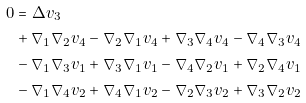Convert formula to latex. <formula><loc_0><loc_0><loc_500><loc_500>0 & = \Delta v _ { 3 } \\ & + \nabla _ { 1 } \nabla _ { 2 } v _ { 4 } - \nabla _ { 2 } \nabla _ { 1 } v _ { 4 } + \nabla _ { 3 } \nabla _ { 4 } v _ { 4 } - \nabla _ { 4 } \nabla _ { 3 } v _ { 4 } \\ & - \nabla _ { 1 } \nabla _ { 3 } v _ { 1 } + \nabla _ { 3 } \nabla _ { 1 } v _ { 1 } - \nabla _ { 4 } \nabla _ { 2 } v _ { 1 } + \nabla _ { 2 } \nabla _ { 4 } v _ { 1 } \\ & - \nabla _ { 1 } \nabla _ { 4 } v _ { 2 } + \nabla _ { 4 } \nabla _ { 1 } v _ { 2 } - \nabla _ { 2 } \nabla _ { 3 } v _ { 2 } + \nabla _ { 3 } \nabla _ { 2 } v _ { 2 }</formula> 